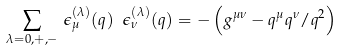<formula> <loc_0><loc_0><loc_500><loc_500>\sum _ { \lambda = 0 , + , - } \, \epsilon ^ { ( \lambda ) } _ { \mu } ( q ) \ \epsilon ^ { ( \lambda ) } _ { \nu } ( q ) = - \left ( g ^ { \mu \nu } - q ^ { \mu } q ^ { \nu } / q ^ { 2 } \right )</formula> 